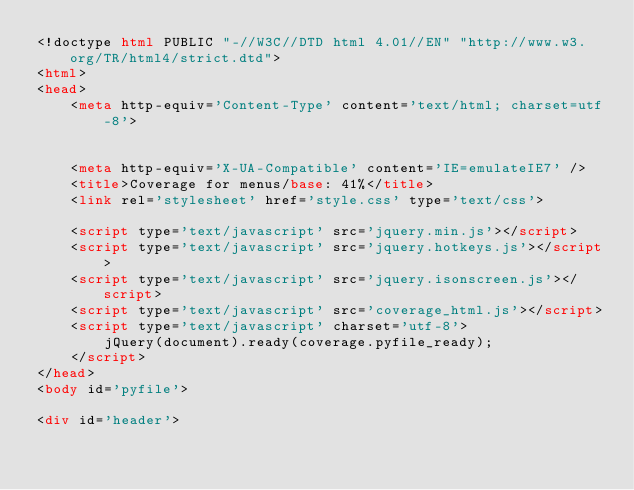<code> <loc_0><loc_0><loc_500><loc_500><_HTML_><!doctype html PUBLIC "-//W3C//DTD html 4.01//EN" "http://www.w3.org/TR/html4/strict.dtd">
<html>
<head>
    <meta http-equiv='Content-Type' content='text/html; charset=utf-8'>
    
    
    <meta http-equiv='X-UA-Compatible' content='IE=emulateIE7' />
    <title>Coverage for menus/base: 41%</title>
    <link rel='stylesheet' href='style.css' type='text/css'>
    
    <script type='text/javascript' src='jquery.min.js'></script>
    <script type='text/javascript' src='jquery.hotkeys.js'></script>
    <script type='text/javascript' src='jquery.isonscreen.js'></script>
    <script type='text/javascript' src='coverage_html.js'></script>
    <script type='text/javascript' charset='utf-8'>
        jQuery(document).ready(coverage.pyfile_ready);
    </script>
</head>
<body id='pyfile'>

<div id='header'></code> 